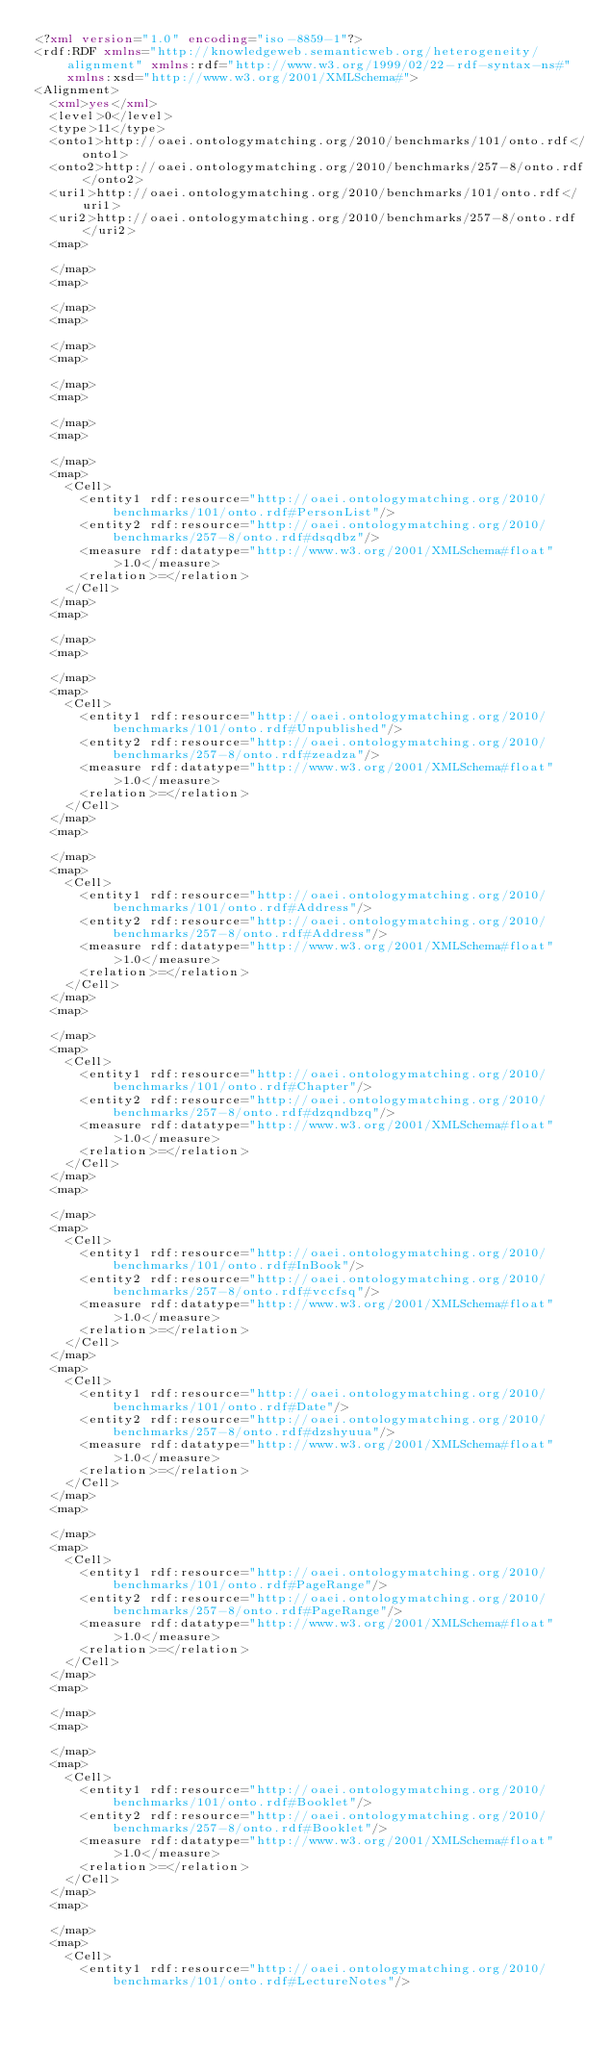Convert code to text. <code><loc_0><loc_0><loc_500><loc_500><_XML_><?xml version="1.0" encoding="iso-8859-1"?>
<rdf:RDF xmlns="http://knowledgeweb.semanticweb.org/heterogeneity/alignment" xmlns:rdf="http://www.w3.org/1999/02/22-rdf-syntax-ns#" xmlns:xsd="http://www.w3.org/2001/XMLSchema#">
<Alignment>
  <xml>yes</xml>
  <level>0</level>
  <type>11</type>
  <onto1>http://oaei.ontologymatching.org/2010/benchmarks/101/onto.rdf</onto1>
  <onto2>http://oaei.ontologymatching.org/2010/benchmarks/257-8/onto.rdf</onto2>
  <uri1>http://oaei.ontologymatching.org/2010/benchmarks/101/onto.rdf</uri1>
  <uri2>http://oaei.ontologymatching.org/2010/benchmarks/257-8/onto.rdf</uri2>
  <map>
    
  </map>
  <map>
    
  </map>
  <map>
    
  </map>
  <map>
    
  </map>
  <map>
    
  </map>
  <map>
    
  </map>
  <map>
    <Cell>
      <entity1 rdf:resource="http://oaei.ontologymatching.org/2010/benchmarks/101/onto.rdf#PersonList"/>
      <entity2 rdf:resource="http://oaei.ontologymatching.org/2010/benchmarks/257-8/onto.rdf#dsqdbz"/>
      <measure rdf:datatype="http://www.w3.org/2001/XMLSchema#float">1.0</measure>
      <relation>=</relation>
    </Cell>
  </map>
  <map>
    
  </map>
  <map>
    
  </map>
  <map>
    <Cell>
      <entity1 rdf:resource="http://oaei.ontologymatching.org/2010/benchmarks/101/onto.rdf#Unpublished"/>
      <entity2 rdf:resource="http://oaei.ontologymatching.org/2010/benchmarks/257-8/onto.rdf#zeadza"/>
      <measure rdf:datatype="http://www.w3.org/2001/XMLSchema#float">1.0</measure>
      <relation>=</relation>
    </Cell>
  </map>
  <map>
    
  </map>
  <map>
    <Cell>
      <entity1 rdf:resource="http://oaei.ontologymatching.org/2010/benchmarks/101/onto.rdf#Address"/>
      <entity2 rdf:resource="http://oaei.ontologymatching.org/2010/benchmarks/257-8/onto.rdf#Address"/>
      <measure rdf:datatype="http://www.w3.org/2001/XMLSchema#float">1.0</measure>
      <relation>=</relation>
    </Cell>
  </map>
  <map>
    
  </map>
  <map>
    <Cell>
      <entity1 rdf:resource="http://oaei.ontologymatching.org/2010/benchmarks/101/onto.rdf#Chapter"/>
      <entity2 rdf:resource="http://oaei.ontologymatching.org/2010/benchmarks/257-8/onto.rdf#dzqndbzq"/>
      <measure rdf:datatype="http://www.w3.org/2001/XMLSchema#float">1.0</measure>
      <relation>=</relation>
    </Cell>
  </map>
  <map>
    
  </map>
  <map>
    <Cell>
      <entity1 rdf:resource="http://oaei.ontologymatching.org/2010/benchmarks/101/onto.rdf#InBook"/>
      <entity2 rdf:resource="http://oaei.ontologymatching.org/2010/benchmarks/257-8/onto.rdf#vccfsq"/>
      <measure rdf:datatype="http://www.w3.org/2001/XMLSchema#float">1.0</measure>
      <relation>=</relation>
    </Cell>
  </map>
  <map>
    <Cell>
      <entity1 rdf:resource="http://oaei.ontologymatching.org/2010/benchmarks/101/onto.rdf#Date"/>
      <entity2 rdf:resource="http://oaei.ontologymatching.org/2010/benchmarks/257-8/onto.rdf#dzshyuua"/>
      <measure rdf:datatype="http://www.w3.org/2001/XMLSchema#float">1.0</measure>
      <relation>=</relation>
    </Cell>
  </map>
  <map>
    
  </map>
  <map>
    <Cell>
      <entity1 rdf:resource="http://oaei.ontologymatching.org/2010/benchmarks/101/onto.rdf#PageRange"/>
      <entity2 rdf:resource="http://oaei.ontologymatching.org/2010/benchmarks/257-8/onto.rdf#PageRange"/>
      <measure rdf:datatype="http://www.w3.org/2001/XMLSchema#float">1.0</measure>
      <relation>=</relation>
    </Cell>
  </map>
  <map>
    
  </map>
  <map>
    
  </map>
  <map>
    <Cell>
      <entity1 rdf:resource="http://oaei.ontologymatching.org/2010/benchmarks/101/onto.rdf#Booklet"/>
      <entity2 rdf:resource="http://oaei.ontologymatching.org/2010/benchmarks/257-8/onto.rdf#Booklet"/>
      <measure rdf:datatype="http://www.w3.org/2001/XMLSchema#float">1.0</measure>
      <relation>=</relation>
    </Cell>
  </map>
  <map>
    
  </map>
  <map>
    <Cell>
      <entity1 rdf:resource="http://oaei.ontologymatching.org/2010/benchmarks/101/onto.rdf#LectureNotes"/></code> 